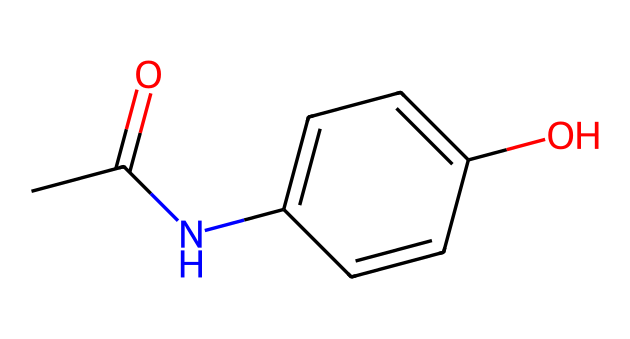What is the molecular formula of acetaminophen? The SMILES representation can be analyzed to count the atoms present: there are 8 carbons (C), 9 hydrogens (H), 1 nitrogen (N), and 2 oxygens (O). Thus, the molecular formula is C8H9NO2.
Answer: C8H9NO2 How many rings are present in the acetaminophen structure? By examining the structure, it's clear that there is one benzene ring present, as indicated by the set of alternating double bonds between the six carbon atoms.
Answer: 1 What functional groups are identified in the acetaminophen molecule? The structure contains several functional groups: an amide group from the NH and C=O, and a hydroxyl group from the -OH. This indicates it has both a >C=O and an -OH functional group.
Answer: amide, hydroxyl What type of bond connects the carbon and nitrogen in acetaminophen? The bond between the carbon (from the acetyl group) and nitrogen in this molecule is a single bond, as indicated in the SMILES representation by the lack of a "=" between the two atoms.
Answer: single bond Does acetaminophen pose any significant hazards when used properly? Generally, when used correctly as directed for pain relief in children, acetaminophen is considered safe; however, improper usage or overdose can pose dangers, emphasizing the importance of following dosing instructions.
Answer: no 